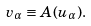Convert formula to latex. <formula><loc_0><loc_0><loc_500><loc_500>v _ { \alpha } \equiv A ( u _ { \alpha } ) .</formula> 